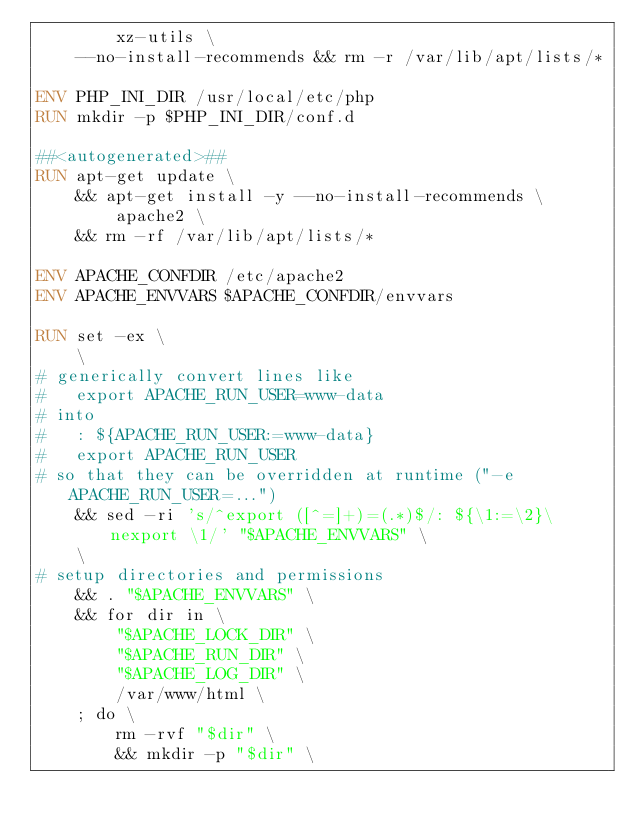Convert code to text. <code><loc_0><loc_0><loc_500><loc_500><_Dockerfile_>		xz-utils \
	--no-install-recommends && rm -r /var/lib/apt/lists/*

ENV PHP_INI_DIR /usr/local/etc/php
RUN mkdir -p $PHP_INI_DIR/conf.d

##<autogenerated>##
RUN apt-get update \
	&& apt-get install -y --no-install-recommends \
		apache2 \
	&& rm -rf /var/lib/apt/lists/*

ENV APACHE_CONFDIR /etc/apache2
ENV APACHE_ENVVARS $APACHE_CONFDIR/envvars

RUN set -ex \
	\
# generically convert lines like
#   export APACHE_RUN_USER=www-data
# into
#   : ${APACHE_RUN_USER:=www-data}
#   export APACHE_RUN_USER
# so that they can be overridden at runtime ("-e APACHE_RUN_USER=...")
	&& sed -ri 's/^export ([^=]+)=(.*)$/: ${\1:=\2}\nexport \1/' "$APACHE_ENVVARS" \
	\
# setup directories and permissions
	&& . "$APACHE_ENVVARS" \
	&& for dir in \
		"$APACHE_LOCK_DIR" \
		"$APACHE_RUN_DIR" \
		"$APACHE_LOG_DIR" \
		/var/www/html \
	; do \
		rm -rvf "$dir" \
		&& mkdir -p "$dir" \</code> 